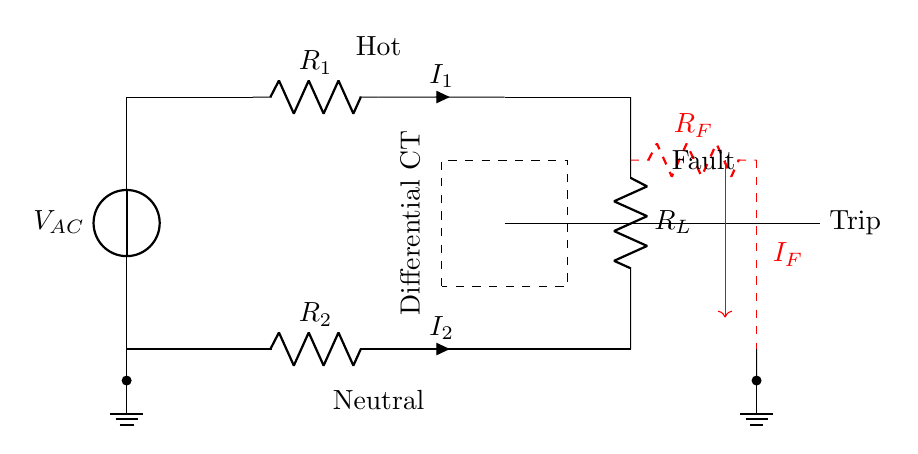What is the primary function of the differential current transformer in this circuit? The differential current transformer monitors the current flow in the hot and neutral wires and detects any imbalance that indicates a ground fault, triggering the trip mechanism.
Answer: Monitor current What does the red dashed line in the diagram represent? The red dashed line indicates the fault path, highlighting where the current would divert to ground in the event of a fault condition.
Answer: Fault path What are the resistance values represented by R1 and R2 assumed to be? R1 and R2 are commonly used as current sensing resistors in a GFCI application; their exact values depend on design specifications, but they typically fall within a few ohms.
Answer: Several ohms What happens when the current through the ground fault path (I_F) exceeds a certain threshold? When the fault current exceeds the threshold, the differential current transformer detects the imbalance and activates the trip mechanism, disconnecting the circuit to prevent shock hazards.
Answer: Circuit trips What are the main voltage and current sources shown in this circuit? The main voltage source is labeled as V_AC, while the currents I_1 and I_2 represent the currents flowing through the resistors R1 and R2, respectively.
Answer: V_AC, I_1, I_2 What could happen if R_F fails to operate correctly? If R_F fails, the circuit could allow excessive ground fault currents to pass through, potentially leading to electric shock or fire hazards since the trip mechanism may not activate.
Answer: Safety risk 